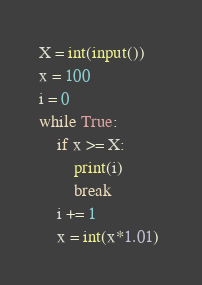<code> <loc_0><loc_0><loc_500><loc_500><_Python_>X = int(input())
x = 100
i = 0
while True:
    if x >= X:
        print(i)
        break
    i += 1
    x = int(x*1.01) </code> 